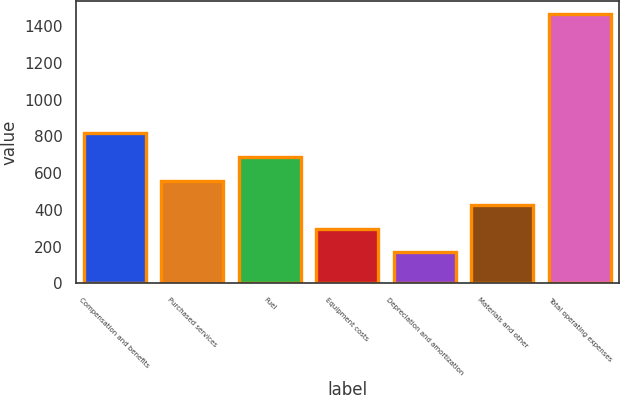Convert chart to OTSL. <chart><loc_0><loc_0><loc_500><loc_500><bar_chart><fcel>Compensation and benefits<fcel>Purchased services<fcel>Fuel<fcel>Equipment costs<fcel>Depreciation and amortization<fcel>Materials and other<fcel>Total operating expenses<nl><fcel>816.25<fcel>556.87<fcel>686.56<fcel>297.49<fcel>167.8<fcel>427.18<fcel>1464.7<nl></chart> 